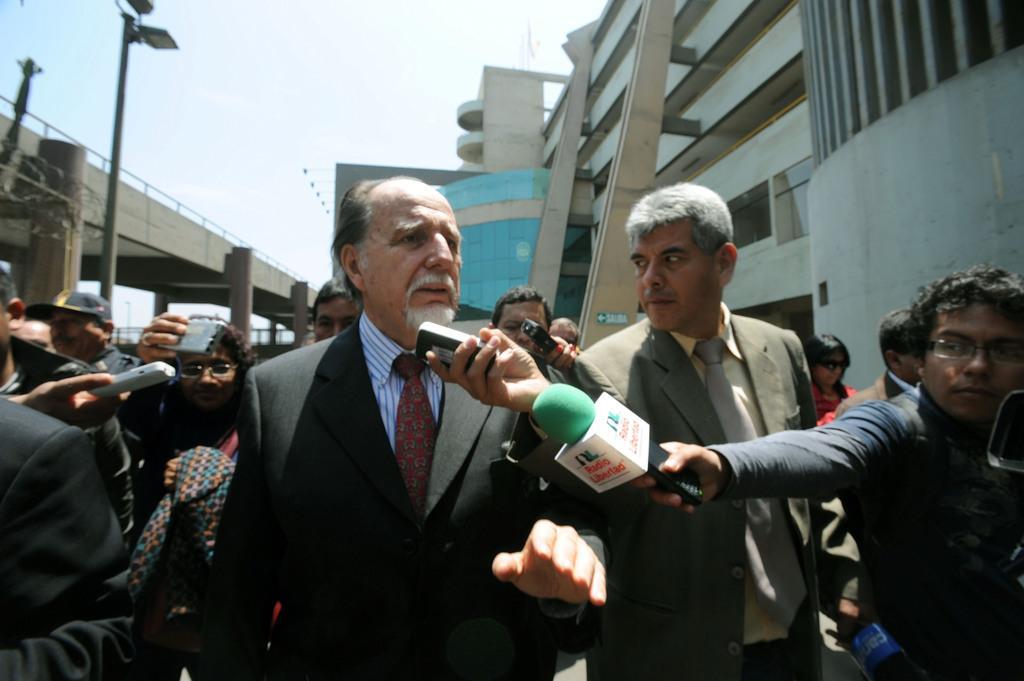Describe this image in one or two sentences. In the center of the image there is a person. Beside him there are people holding the mikes, recorders. On the left side of the image there is a bridge. There are poles. On the right side of the image there are buildings. In the background of the image there is sky. 